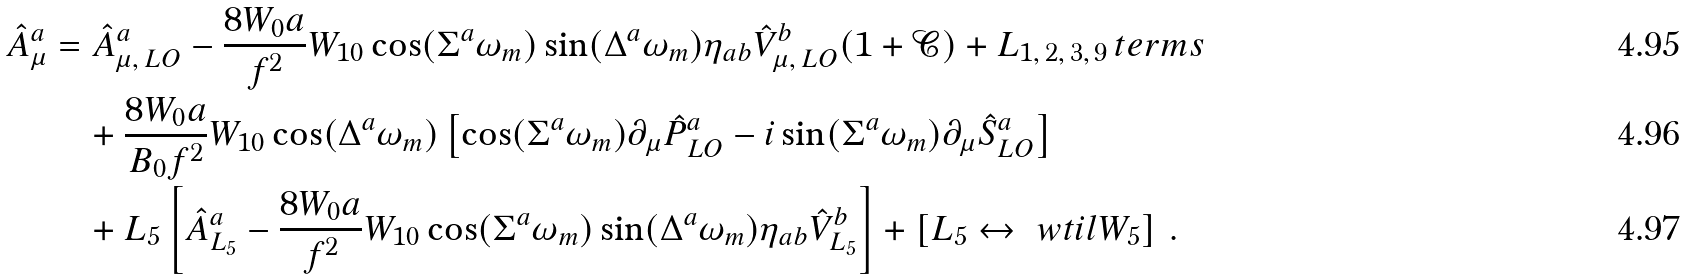<formula> <loc_0><loc_0><loc_500><loc_500>\hat { A } ^ { a } _ { \mu } & = \hat { A } ^ { a } _ { \mu , \, L O } - \frac { 8 W _ { 0 } a } { f ^ { 2 } } W _ { 1 0 } \cos ( \Sigma ^ { a } \omega _ { m } ) \sin ( \Delta ^ { a } \omega _ { m } ) \eta _ { a b } \hat { V } ^ { b } _ { \mu , \, L O } ( 1 + \mathcal { C } ) + L _ { 1 , \, 2 , \, 3 , \, 9 } \, t e r m s \\ & \quad + \frac { 8 W _ { 0 } a } { B _ { 0 } f ^ { 2 } } W _ { 1 0 } \cos ( \Delta ^ { a } \omega _ { m } ) \left [ \cos ( \Sigma ^ { a } \omega _ { m } ) \partial _ { \mu } \hat { P } ^ { a } _ { L O } - i \sin ( \Sigma ^ { a } \omega _ { m } ) \partial _ { \mu } \hat { S } ^ { a } _ { L O } \right ] \\ & \quad + L _ { 5 } \left [ \hat { A } ^ { a } _ { L _ { 5 } } - \frac { 8 W _ { 0 } a } { f ^ { 2 } } W _ { 1 0 } \cos ( \Sigma ^ { a } \omega _ { m } ) \sin ( \Delta ^ { a } \omega _ { m } ) \eta _ { a b } \hat { V } ^ { b } _ { L _ { 5 } } \right ] + \left [ L _ { 5 } \leftrightarrow \ w t i l { W } _ { 5 } \right ] \, .</formula> 